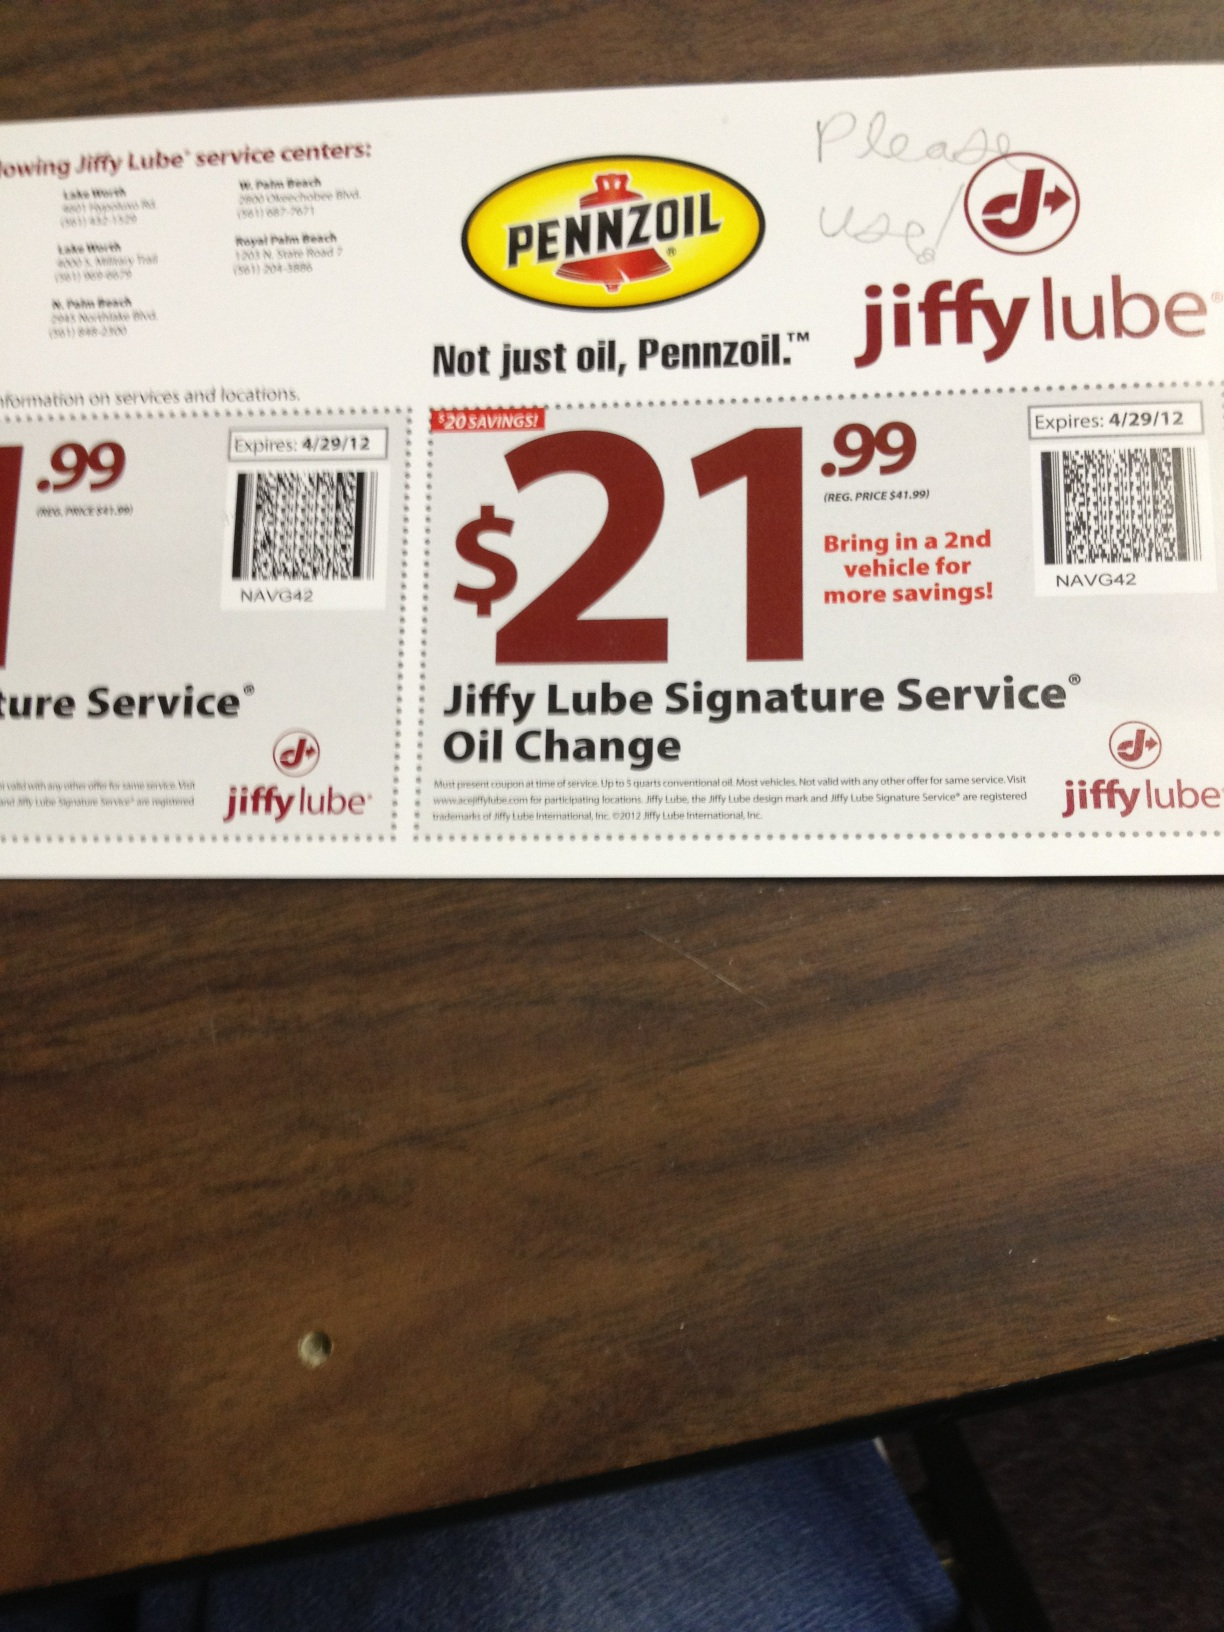What is this? This is a coupon for a $21.99 Jiffy Lube Signature Service Oil Change, featuring Pennzoil oil. The coupon offers a $20 saving from the regular price of $41.99 and an additional savings opportunity if you bring in a second vehicle. It's valid until April 29, 2012, and is applicable at specific Jiffy Lube service centers mentioned on the coupon. 